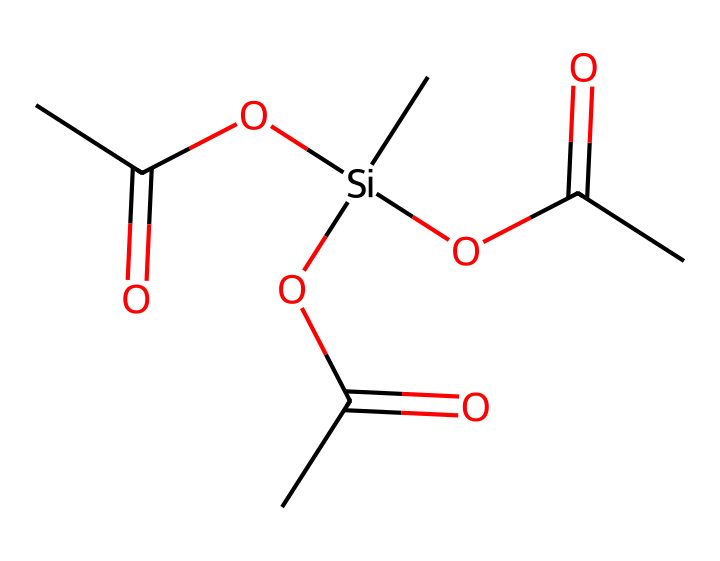What is the total number of carbon atoms in this chemical? By examining the SMILES representation closely, we can count three distinct carbon groups indicated by the "C" symbols. There are two carbonyl groups as well, so we total them together: 3 + 3 from the three carboxyl groups brings us to 6 carbon atoms.
Answer: six How many silicon atoms does this chemical contain? The SMILES representation shows a single "Si" indicating that there is only one silicon atom present in this structure.
Answer: one What functional groups are present in this silane-based adhesive? The chemical structure contains three ester groups represented by "OC(C)=O", which indicates the presence of ester functional groups attached to the silicon atom, contributing to its adhesive properties.
Answer: ester Is this chemical polar or nonpolar? The presence of multiple polar functional groups, such as the ester, leads to a higher degree of polarity in this compound compared to nonpolar molecules. Therefore, we can classify this chemical as polar.
Answer: polar How many total oxygen atoms are present in the compound? In the SMILES representation, we count three oxygen atoms from the ester groups connected to the silicon atom, hence the total number of oxygen atoms is three.
Answer: three What type of reaction would likely be used to synthesize this silane-based adhesive? Considering the structure has multiple ester groups, it suggests that the synthesis might involve a condensation reaction between an alcohol group and a carboxylic acid.
Answer: condensation reaction 